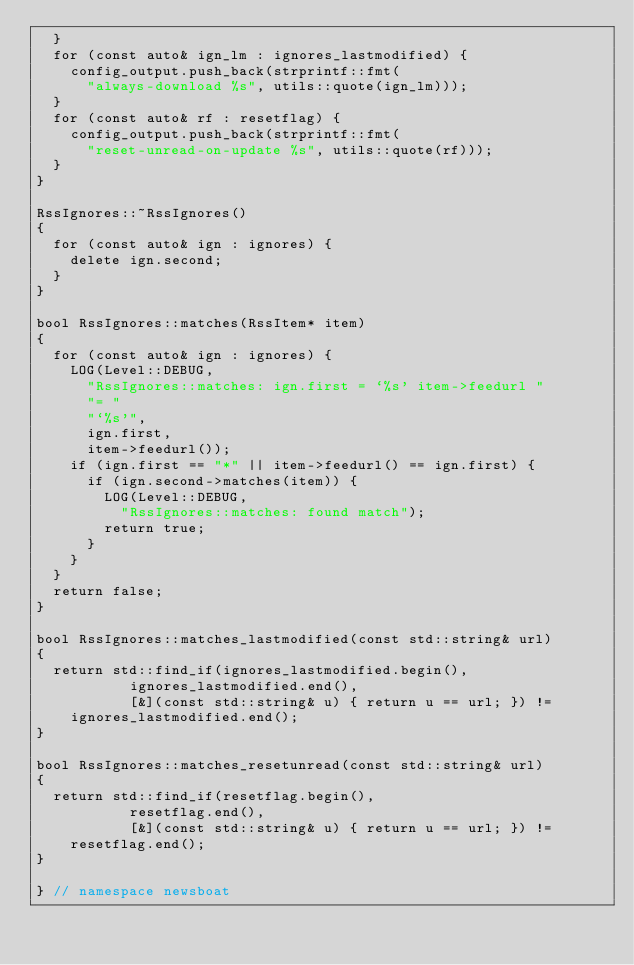<code> <loc_0><loc_0><loc_500><loc_500><_C++_>	}
	for (const auto& ign_lm : ignores_lastmodified) {
		config_output.push_back(strprintf::fmt(
			"always-download %s", utils::quote(ign_lm)));
	}
	for (const auto& rf : resetflag) {
		config_output.push_back(strprintf::fmt(
			"reset-unread-on-update %s", utils::quote(rf)));
	}
}

RssIgnores::~RssIgnores()
{
	for (const auto& ign : ignores) {
		delete ign.second;
	}
}

bool RssIgnores::matches(RssItem* item)
{
	for (const auto& ign : ignores) {
		LOG(Level::DEBUG,
			"RssIgnores::matches: ign.first = `%s' item->feedurl "
			"= "
			"`%s'",
			ign.first,
			item->feedurl());
		if (ign.first == "*" || item->feedurl() == ign.first) {
			if (ign.second->matches(item)) {
				LOG(Level::DEBUG,
					"RssIgnores::matches: found match");
				return true;
			}
		}
	}
	return false;
}

bool RssIgnores::matches_lastmodified(const std::string& url)
{
	return std::find_if(ignores_lastmodified.begin(),
		       ignores_lastmodified.end(),
		       [&](const std::string& u) { return u == url; }) !=
		ignores_lastmodified.end();
}

bool RssIgnores::matches_resetunread(const std::string& url)
{
	return std::find_if(resetflag.begin(),
		       resetflag.end(),
		       [&](const std::string& u) { return u == url; }) !=
		resetflag.end();
}

} // namespace newsboat
</code> 